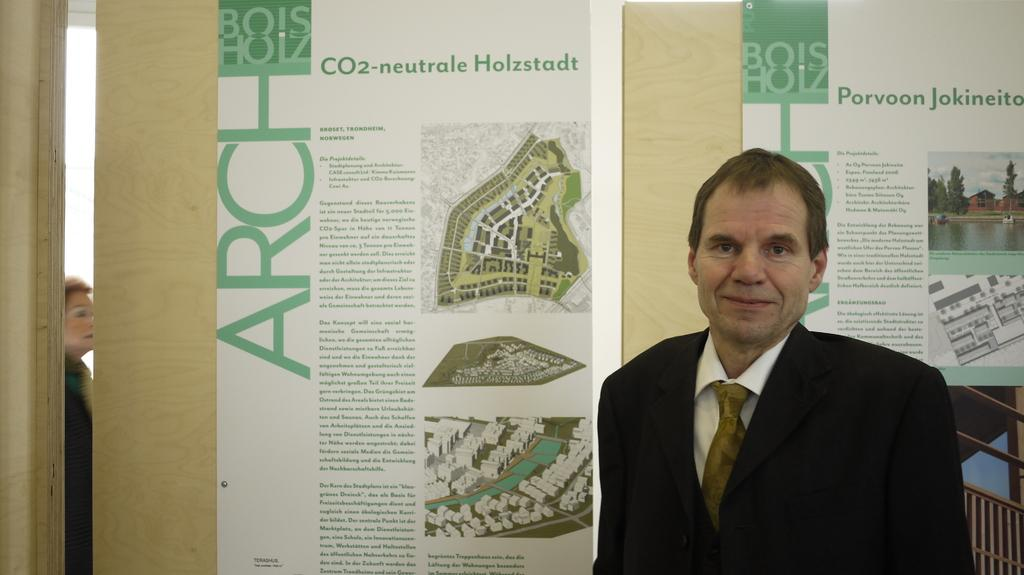What is the main subject of the image? There is a man standing in the image. What else can be seen in the image besides the man? There are boards with text and pictures in the image. Are there any other people in the image? Yes, there is a woman in the image. What type of branch can be seen in the woman's hand in the image? There is no branch present in the image; the woman does not have any objects in her hand. 